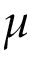Convert formula to latex. <formula><loc_0><loc_0><loc_500><loc_500>\mu</formula> 